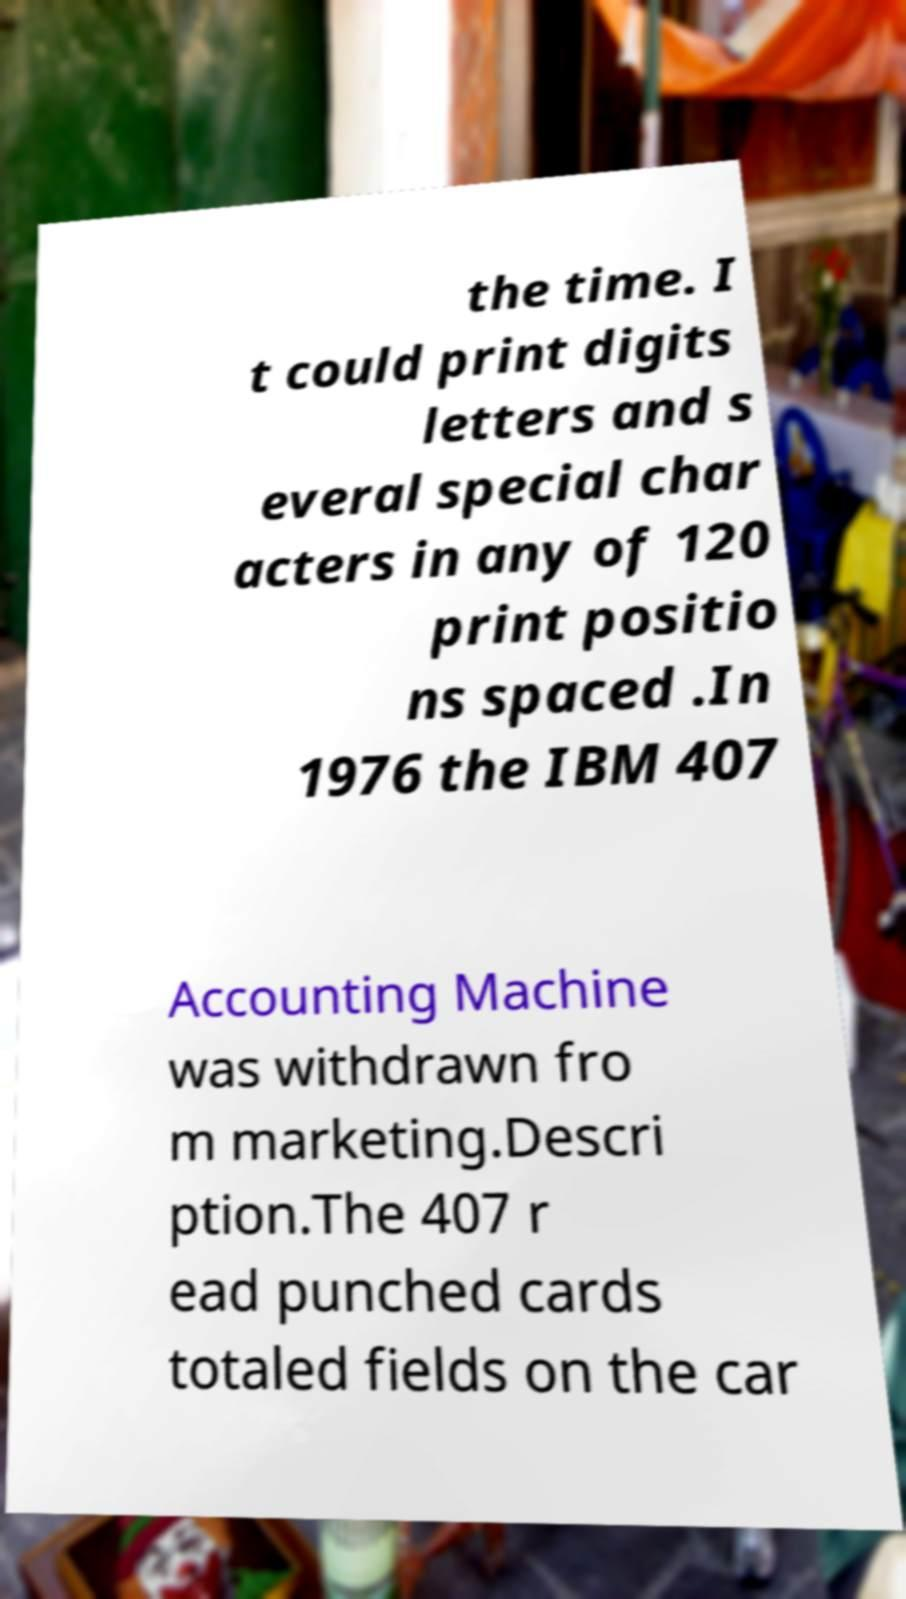Please identify and transcribe the text found in this image. the time. I t could print digits letters and s everal special char acters in any of 120 print positio ns spaced .In 1976 the IBM 407 Accounting Machine was withdrawn fro m marketing.Descri ption.The 407 r ead punched cards totaled fields on the car 